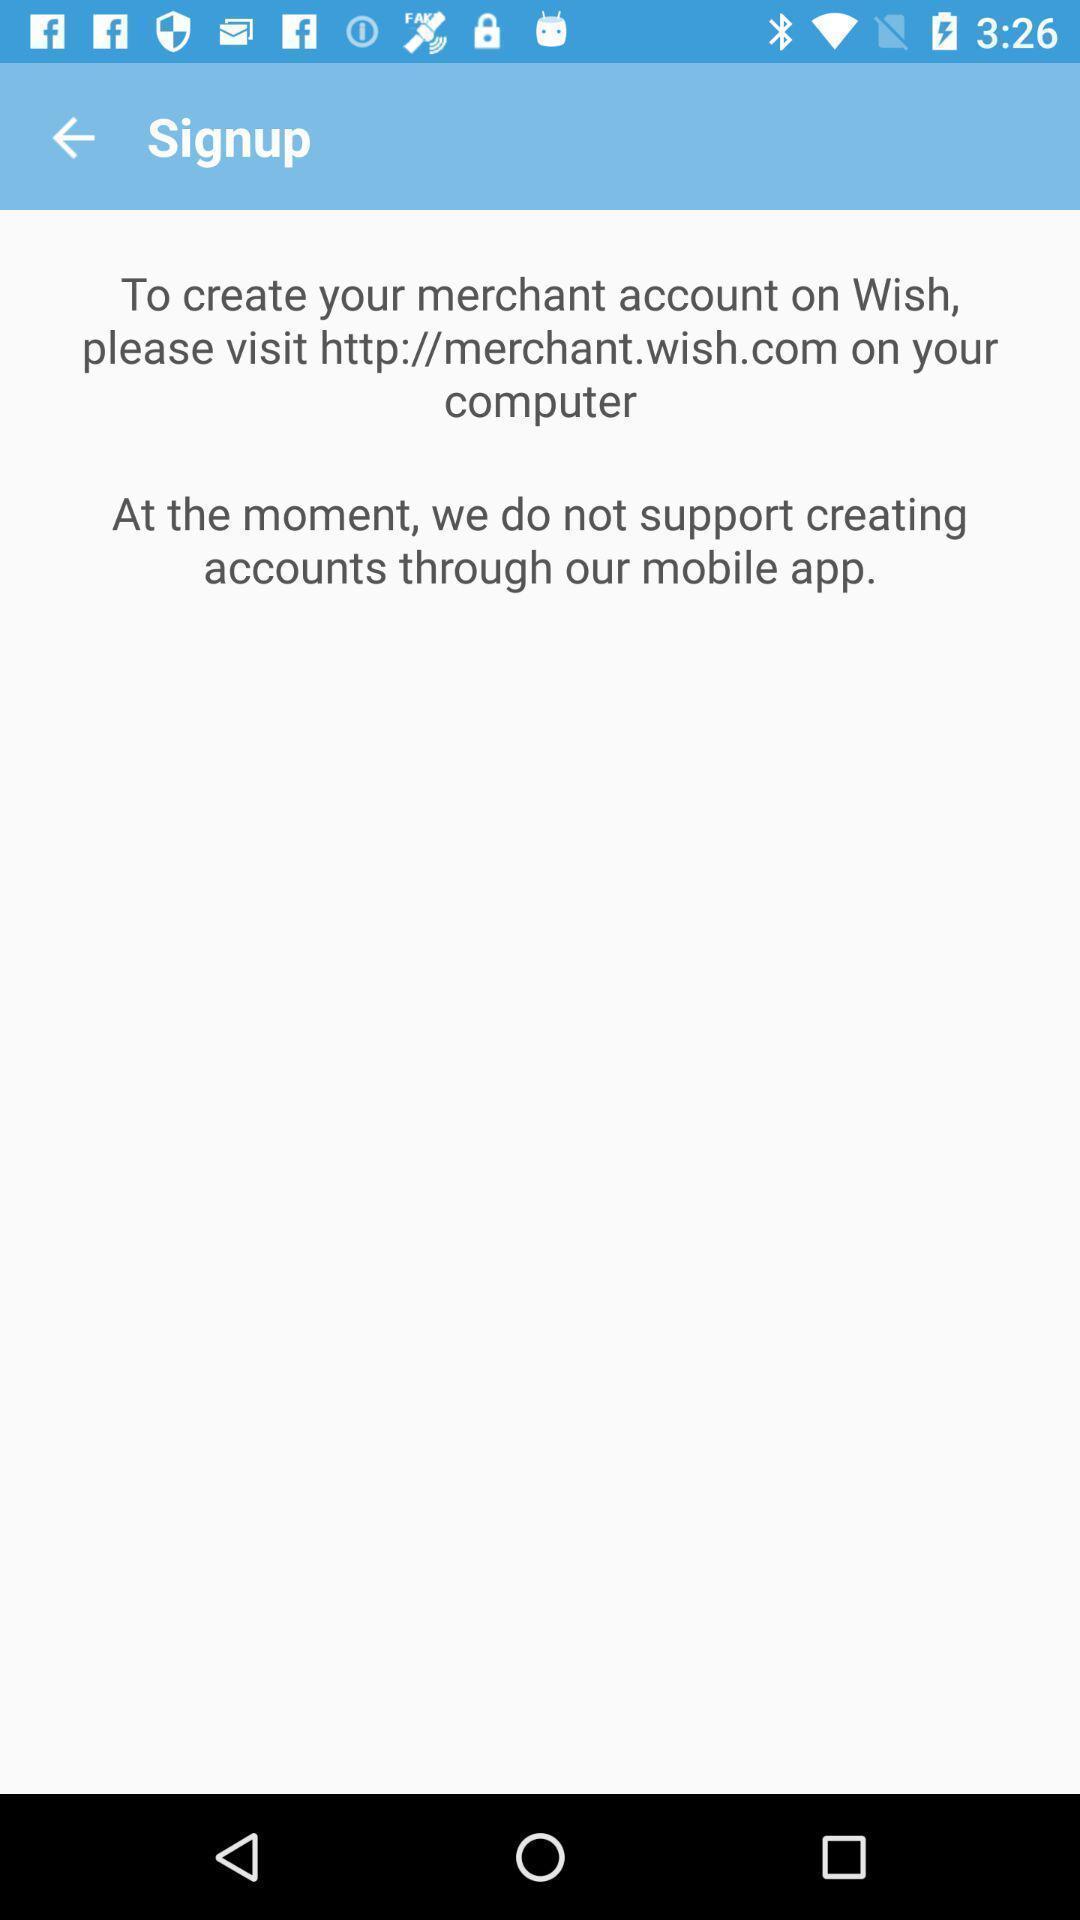Describe the visual elements of this screenshot. Signup page for a commerce app. 